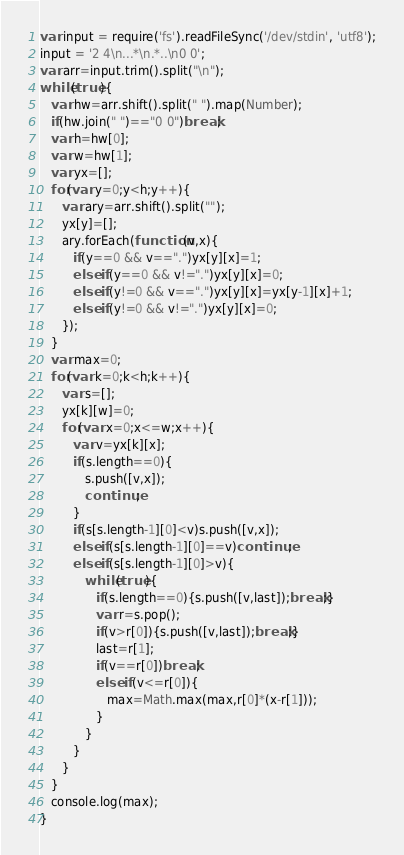<code> <loc_0><loc_0><loc_500><loc_500><_JavaScript_>var input = require('fs').readFileSync('/dev/stdin', 'utf8');
input = '2 4\n...*\n.*..\n0 0';
var arr=input.trim().split("\n");
while(true){
   var hw=arr.shift().split(" ").map(Number);
   if(hw.join(" ")=="0 0")break;
   var h=hw[0];
   var w=hw[1];
   var yx=[];
   for(var y=0;y<h;y++){
      var ary=arr.shift().split("");
      yx[y]=[];
      ary.forEach(function(v,x){
         if(y==0 && v==".")yx[y][x]=1;
         else if(y==0 && v!=".")yx[y][x]=0;
         else if(y!=0 && v==".")yx[y][x]=yx[y-1][x]+1;
         else if(y!=0 && v!=".")yx[y][x]=0;
      });
   }
   var max=0;
   for(var k=0;k<h;k++){
      var s=[];
      yx[k][w]=0;
      for(var x=0;x<=w;x++){
         var v=yx[k][x];
         if(s.length==0){
            s.push([v,x]);
            continue;
         }
         if(s[s.length-1][0]<v)s.push([v,x]);
         else if(s[s.length-1][0]==v)continue;
         else if(s[s.length-1][0]>v){
            while(true){
               if(s.length==0){s.push([v,last]);break;}
               var r=s.pop();
               if(v>r[0]){s.push([v,last]);break;}
               last=r[1];
               if(v==r[0])break;
               else if(v<=r[0]){
                  max=Math.max(max,r[0]*(x-r[1]));
               }
            }
         }
      }
   }
   console.log(max);
}</code> 